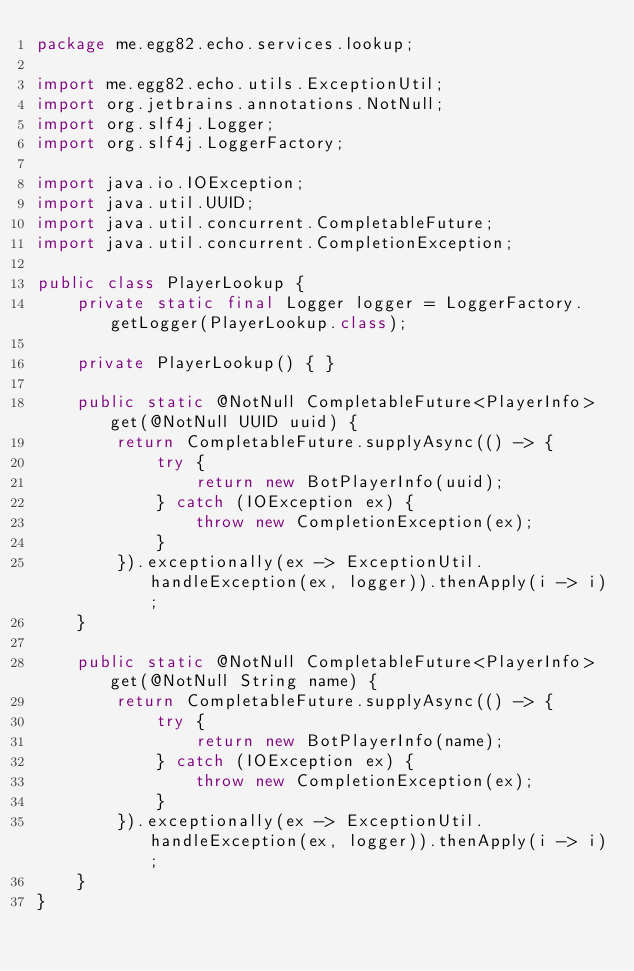<code> <loc_0><loc_0><loc_500><loc_500><_Java_>package me.egg82.echo.services.lookup;

import me.egg82.echo.utils.ExceptionUtil;
import org.jetbrains.annotations.NotNull;
import org.slf4j.Logger;
import org.slf4j.LoggerFactory;

import java.io.IOException;
import java.util.UUID;
import java.util.concurrent.CompletableFuture;
import java.util.concurrent.CompletionException;

public class PlayerLookup {
    private static final Logger logger = LoggerFactory.getLogger(PlayerLookup.class);

    private PlayerLookup() { }

    public static @NotNull CompletableFuture<PlayerInfo> get(@NotNull UUID uuid) {
        return CompletableFuture.supplyAsync(() -> {
            try {
                return new BotPlayerInfo(uuid);
            } catch (IOException ex) {
                throw new CompletionException(ex);
            }
        }).exceptionally(ex -> ExceptionUtil.handleException(ex, logger)).thenApply(i -> i);
    }

    public static @NotNull CompletableFuture<PlayerInfo> get(@NotNull String name) {
        return CompletableFuture.supplyAsync(() -> {
            try {
                return new BotPlayerInfo(name);
            } catch (IOException ex) {
                throw new CompletionException(ex);
            }
        }).exceptionally(ex -> ExceptionUtil.handleException(ex, logger)).thenApply(i -> i);
    }
}
</code> 